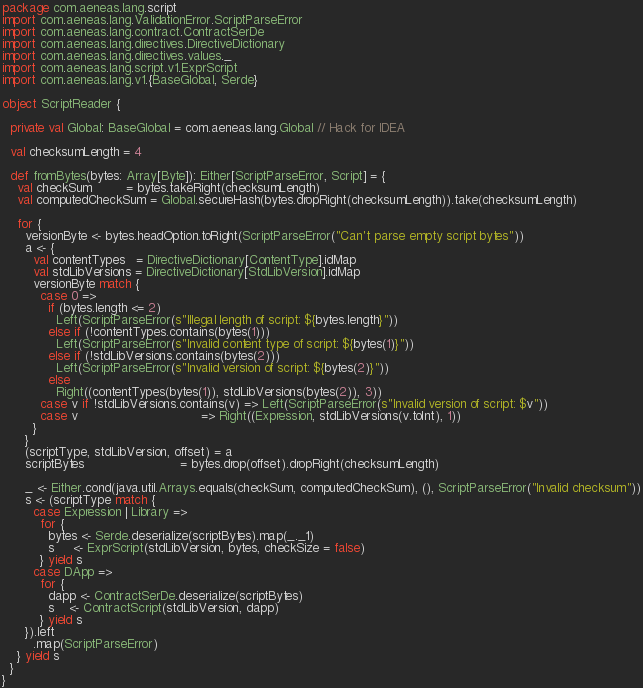Convert code to text. <code><loc_0><loc_0><loc_500><loc_500><_Scala_>package com.aeneas.lang.script
import com.aeneas.lang.ValidationError.ScriptParseError
import com.aeneas.lang.contract.ContractSerDe
import com.aeneas.lang.directives.DirectiveDictionary
import com.aeneas.lang.directives.values._
import com.aeneas.lang.script.v1.ExprScript
import com.aeneas.lang.v1.{BaseGlobal, Serde}

object ScriptReader {

  private val Global: BaseGlobal = com.aeneas.lang.Global // Hack for IDEA

  val checksumLength = 4

  def fromBytes(bytes: Array[Byte]): Either[ScriptParseError, Script] = {
    val checkSum         = bytes.takeRight(checksumLength)
    val computedCheckSum = Global.secureHash(bytes.dropRight(checksumLength)).take(checksumLength)

    for {
      versionByte <- bytes.headOption.toRight(ScriptParseError("Can't parse empty script bytes"))
      a <- {
        val contentTypes   = DirectiveDictionary[ContentType].idMap
        val stdLibVersions = DirectiveDictionary[StdLibVersion].idMap
        versionByte match {
          case 0 =>
            if (bytes.length <= 2)
              Left(ScriptParseError(s"Illegal length of script: ${bytes.length}"))
            else if (!contentTypes.contains(bytes(1)))
              Left(ScriptParseError(s"Invalid content type of script: ${bytes(1)}"))
            else if (!stdLibVersions.contains(bytes(2)))
              Left(ScriptParseError(s"Invalid version of script: ${bytes(2)}"))
            else
              Right((contentTypes(bytes(1)), stdLibVersions(bytes(2)), 3))
          case v if !stdLibVersions.contains(v) => Left(ScriptParseError(s"Invalid version of script: $v"))
          case v                                => Right((Expression, stdLibVersions(v.toInt), 1))
        }
      }
      (scriptType, stdLibVersion, offset) = a
      scriptBytes                         = bytes.drop(offset).dropRight(checksumLength)

      _ <- Either.cond(java.util.Arrays.equals(checkSum, computedCheckSum), (), ScriptParseError("Invalid checksum"))
      s <- (scriptType match {
        case Expression | Library =>
          for {
            bytes <- Serde.deserialize(scriptBytes).map(_._1)
            s     <- ExprScript(stdLibVersion, bytes, checkSize = false)
          } yield s
        case DApp =>
          for {
            dapp <- ContractSerDe.deserialize(scriptBytes)
            s    <- ContractScript(stdLibVersion, dapp)
          } yield s
      }).left
        .map(ScriptParseError)
    } yield s
  }
}
</code> 